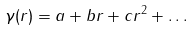Convert formula to latex. <formula><loc_0><loc_0><loc_500><loc_500>\gamma ( r ) = a + b r + c r ^ { 2 } + \dots</formula> 